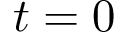<formula> <loc_0><loc_0><loc_500><loc_500>t = 0</formula> 